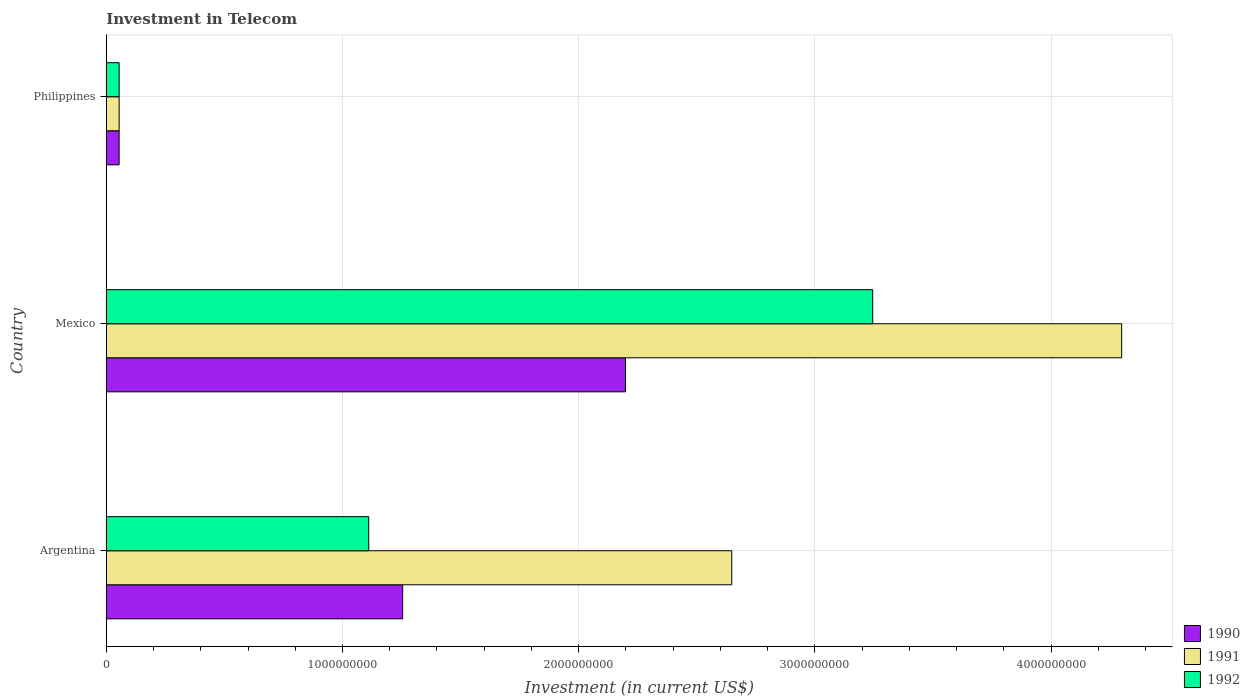How many different coloured bars are there?
Provide a short and direct response. 3. How many bars are there on the 3rd tick from the bottom?
Keep it short and to the point. 3. What is the label of the 3rd group of bars from the top?
Keep it short and to the point. Argentina. In how many cases, is the number of bars for a given country not equal to the number of legend labels?
Keep it short and to the point. 0. What is the amount invested in telecom in 1991 in Argentina?
Offer a very short reply. 2.65e+09. Across all countries, what is the maximum amount invested in telecom in 1990?
Keep it short and to the point. 2.20e+09. Across all countries, what is the minimum amount invested in telecom in 1992?
Your response must be concise. 5.42e+07. In which country was the amount invested in telecom in 1992 maximum?
Your answer should be compact. Mexico. What is the total amount invested in telecom in 1992 in the graph?
Your response must be concise. 4.41e+09. What is the difference between the amount invested in telecom in 1992 in Argentina and that in Philippines?
Provide a short and direct response. 1.06e+09. What is the difference between the amount invested in telecom in 1991 in Philippines and the amount invested in telecom in 1992 in Mexico?
Your response must be concise. -3.19e+09. What is the average amount invested in telecom in 1990 per country?
Your response must be concise. 1.17e+09. What is the ratio of the amount invested in telecom in 1990 in Argentina to that in Philippines?
Give a very brief answer. 23.15. Is the amount invested in telecom in 1991 in Argentina less than that in Mexico?
Keep it short and to the point. Yes. Is the difference between the amount invested in telecom in 1991 in Argentina and Mexico greater than the difference between the amount invested in telecom in 1990 in Argentina and Mexico?
Offer a terse response. No. What is the difference between the highest and the second highest amount invested in telecom in 1991?
Provide a succinct answer. 1.65e+09. What is the difference between the highest and the lowest amount invested in telecom in 1990?
Your response must be concise. 2.14e+09. In how many countries, is the amount invested in telecom in 1991 greater than the average amount invested in telecom in 1991 taken over all countries?
Ensure brevity in your answer.  2. Is the sum of the amount invested in telecom in 1991 in Argentina and Mexico greater than the maximum amount invested in telecom in 1990 across all countries?
Offer a very short reply. Yes. What does the 1st bar from the top in Mexico represents?
Your response must be concise. 1992. What does the 1st bar from the bottom in Mexico represents?
Your answer should be very brief. 1990. Is it the case that in every country, the sum of the amount invested in telecom in 1991 and amount invested in telecom in 1992 is greater than the amount invested in telecom in 1990?
Your answer should be compact. Yes. Are all the bars in the graph horizontal?
Provide a succinct answer. Yes. How many countries are there in the graph?
Your response must be concise. 3. Are the values on the major ticks of X-axis written in scientific E-notation?
Provide a succinct answer. No. Does the graph contain any zero values?
Ensure brevity in your answer.  No. Where does the legend appear in the graph?
Offer a very short reply. Bottom right. How many legend labels are there?
Offer a terse response. 3. How are the legend labels stacked?
Your answer should be compact. Vertical. What is the title of the graph?
Make the answer very short. Investment in Telecom. Does "2008" appear as one of the legend labels in the graph?
Make the answer very short. No. What is the label or title of the X-axis?
Ensure brevity in your answer.  Investment (in current US$). What is the label or title of the Y-axis?
Ensure brevity in your answer.  Country. What is the Investment (in current US$) in 1990 in Argentina?
Provide a short and direct response. 1.25e+09. What is the Investment (in current US$) of 1991 in Argentina?
Your answer should be very brief. 2.65e+09. What is the Investment (in current US$) of 1992 in Argentina?
Provide a succinct answer. 1.11e+09. What is the Investment (in current US$) of 1990 in Mexico?
Make the answer very short. 2.20e+09. What is the Investment (in current US$) of 1991 in Mexico?
Provide a short and direct response. 4.30e+09. What is the Investment (in current US$) of 1992 in Mexico?
Provide a short and direct response. 3.24e+09. What is the Investment (in current US$) in 1990 in Philippines?
Provide a succinct answer. 5.42e+07. What is the Investment (in current US$) in 1991 in Philippines?
Your answer should be very brief. 5.42e+07. What is the Investment (in current US$) of 1992 in Philippines?
Provide a succinct answer. 5.42e+07. Across all countries, what is the maximum Investment (in current US$) of 1990?
Make the answer very short. 2.20e+09. Across all countries, what is the maximum Investment (in current US$) in 1991?
Keep it short and to the point. 4.30e+09. Across all countries, what is the maximum Investment (in current US$) of 1992?
Provide a succinct answer. 3.24e+09. Across all countries, what is the minimum Investment (in current US$) in 1990?
Ensure brevity in your answer.  5.42e+07. Across all countries, what is the minimum Investment (in current US$) in 1991?
Offer a very short reply. 5.42e+07. Across all countries, what is the minimum Investment (in current US$) of 1992?
Provide a short and direct response. 5.42e+07. What is the total Investment (in current US$) in 1990 in the graph?
Your answer should be very brief. 3.51e+09. What is the total Investment (in current US$) in 1991 in the graph?
Make the answer very short. 7.00e+09. What is the total Investment (in current US$) in 1992 in the graph?
Ensure brevity in your answer.  4.41e+09. What is the difference between the Investment (in current US$) in 1990 in Argentina and that in Mexico?
Your answer should be very brief. -9.43e+08. What is the difference between the Investment (in current US$) in 1991 in Argentina and that in Mexico?
Your response must be concise. -1.65e+09. What is the difference between the Investment (in current US$) of 1992 in Argentina and that in Mexico?
Ensure brevity in your answer.  -2.13e+09. What is the difference between the Investment (in current US$) of 1990 in Argentina and that in Philippines?
Keep it short and to the point. 1.20e+09. What is the difference between the Investment (in current US$) in 1991 in Argentina and that in Philippines?
Your response must be concise. 2.59e+09. What is the difference between the Investment (in current US$) in 1992 in Argentina and that in Philippines?
Offer a terse response. 1.06e+09. What is the difference between the Investment (in current US$) of 1990 in Mexico and that in Philippines?
Your response must be concise. 2.14e+09. What is the difference between the Investment (in current US$) of 1991 in Mexico and that in Philippines?
Keep it short and to the point. 4.24e+09. What is the difference between the Investment (in current US$) in 1992 in Mexico and that in Philippines?
Your answer should be very brief. 3.19e+09. What is the difference between the Investment (in current US$) of 1990 in Argentina and the Investment (in current US$) of 1991 in Mexico?
Offer a terse response. -3.04e+09. What is the difference between the Investment (in current US$) in 1990 in Argentina and the Investment (in current US$) in 1992 in Mexico?
Make the answer very short. -1.99e+09. What is the difference between the Investment (in current US$) in 1991 in Argentina and the Investment (in current US$) in 1992 in Mexico?
Offer a very short reply. -5.97e+08. What is the difference between the Investment (in current US$) in 1990 in Argentina and the Investment (in current US$) in 1991 in Philippines?
Your response must be concise. 1.20e+09. What is the difference between the Investment (in current US$) in 1990 in Argentina and the Investment (in current US$) in 1992 in Philippines?
Your answer should be compact. 1.20e+09. What is the difference between the Investment (in current US$) of 1991 in Argentina and the Investment (in current US$) of 1992 in Philippines?
Your response must be concise. 2.59e+09. What is the difference between the Investment (in current US$) of 1990 in Mexico and the Investment (in current US$) of 1991 in Philippines?
Provide a short and direct response. 2.14e+09. What is the difference between the Investment (in current US$) in 1990 in Mexico and the Investment (in current US$) in 1992 in Philippines?
Offer a very short reply. 2.14e+09. What is the difference between the Investment (in current US$) in 1991 in Mexico and the Investment (in current US$) in 1992 in Philippines?
Keep it short and to the point. 4.24e+09. What is the average Investment (in current US$) in 1990 per country?
Give a very brief answer. 1.17e+09. What is the average Investment (in current US$) in 1991 per country?
Keep it short and to the point. 2.33e+09. What is the average Investment (in current US$) of 1992 per country?
Give a very brief answer. 1.47e+09. What is the difference between the Investment (in current US$) of 1990 and Investment (in current US$) of 1991 in Argentina?
Your answer should be very brief. -1.39e+09. What is the difference between the Investment (in current US$) of 1990 and Investment (in current US$) of 1992 in Argentina?
Keep it short and to the point. 1.44e+08. What is the difference between the Investment (in current US$) in 1991 and Investment (in current US$) in 1992 in Argentina?
Keep it short and to the point. 1.54e+09. What is the difference between the Investment (in current US$) in 1990 and Investment (in current US$) in 1991 in Mexico?
Give a very brief answer. -2.10e+09. What is the difference between the Investment (in current US$) of 1990 and Investment (in current US$) of 1992 in Mexico?
Offer a terse response. -1.05e+09. What is the difference between the Investment (in current US$) of 1991 and Investment (in current US$) of 1992 in Mexico?
Ensure brevity in your answer.  1.05e+09. What is the ratio of the Investment (in current US$) of 1990 in Argentina to that in Mexico?
Make the answer very short. 0.57. What is the ratio of the Investment (in current US$) of 1991 in Argentina to that in Mexico?
Your answer should be compact. 0.62. What is the ratio of the Investment (in current US$) of 1992 in Argentina to that in Mexico?
Your answer should be very brief. 0.34. What is the ratio of the Investment (in current US$) of 1990 in Argentina to that in Philippines?
Offer a terse response. 23.15. What is the ratio of the Investment (in current US$) of 1991 in Argentina to that in Philippines?
Make the answer very short. 48.86. What is the ratio of the Investment (in current US$) in 1992 in Argentina to that in Philippines?
Provide a succinct answer. 20.5. What is the ratio of the Investment (in current US$) in 1990 in Mexico to that in Philippines?
Offer a very short reply. 40.55. What is the ratio of the Investment (in current US$) in 1991 in Mexico to that in Philippines?
Make the answer very short. 79.32. What is the ratio of the Investment (in current US$) in 1992 in Mexico to that in Philippines?
Provide a short and direct response. 59.87. What is the difference between the highest and the second highest Investment (in current US$) in 1990?
Offer a terse response. 9.43e+08. What is the difference between the highest and the second highest Investment (in current US$) in 1991?
Ensure brevity in your answer.  1.65e+09. What is the difference between the highest and the second highest Investment (in current US$) of 1992?
Keep it short and to the point. 2.13e+09. What is the difference between the highest and the lowest Investment (in current US$) of 1990?
Make the answer very short. 2.14e+09. What is the difference between the highest and the lowest Investment (in current US$) of 1991?
Your answer should be compact. 4.24e+09. What is the difference between the highest and the lowest Investment (in current US$) of 1992?
Keep it short and to the point. 3.19e+09. 